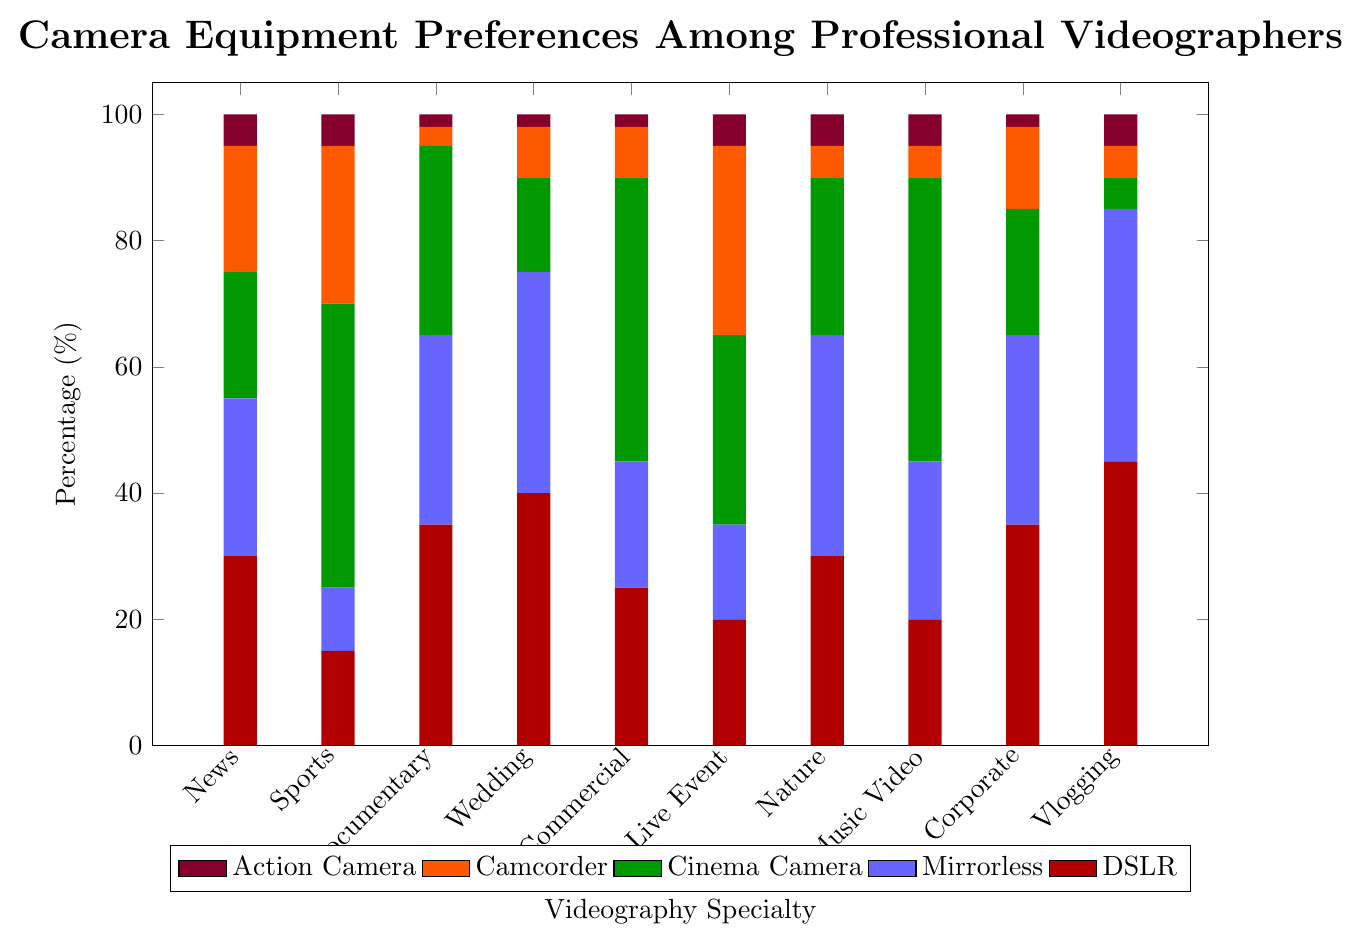Which specialty has the highest percentage of DSLR usage? To find this, we need to look at the red bars representing DSLR usage and identify the tallest one. The tallest bar for DSLR is in the "Vlogging/Social Media" specialty.
Answer: Vlogging/Social Media What is the difference in Cinema Camera usage between "Sports Broadcasting" and "Corporate Video"? First, locate the green bars representing Cinema Camera usage. In "Sports Broadcasting," the Cinema Camera usage is 45%. In "Corporate Video," it is 20%. The difference is calculated as 45 - 20.
Answer: 25% Which specialty has the lowest usage of Mirrorless cameras? To find this, identify the shortest blue bar, representing Mirrorless camera usage. The shortest blue bar is in the "Sports Broadcasting" specialty with a height of 10%.
Answer: Sports Broadcasting How much more preferred are DSLRs compared to Cinema Cameras in "Wedding Videography"? For "Wedding Videography," the usage of DSLRs is 40% (red bar) and Cinema Cameras is 15% (green bar). The difference is 40 - 15.
Answer: 25% What is the total usage percentage of DSLR and Mirrorless cameras in "Documentary Filmmaking"? In "Documentary Filmmaking," DSLRs have a usage of 35% and Mirrorless cameras have a usage of 30%. The total is 35 + 30.
Answer: 65% Which specialty prefers Action Cameras the least? Locate the shortest purple bar, representing Action Camera usage. The shortest bar appears across multiple specialties (Documentary Filmmaking, Wedding Videography, Commercial Production, Corporate Video), all at 2%.
Answer: Documentary Filmmaking, Wedding Videography, Commercial Production, Corporate Video In which specialty are Camcorders used more than Mirrorless cameras? Compare the orange bars (Camcorders) and blue bars (Mirrorless) for each specialty to find where the orange bars are taller. This condition is met in "Live Event Coverage."
Answer: Live Event Coverage What is the combined usage of Cinema Cameras and Camcorders in "Nature/Wildlife Filming"? Cinema Cameras have a usage of 25% (green bar) and Camcorders have a usage of 5% (orange bar) in "Nature/Wildlife Filming." The total is 25 + 5.
Answer: 30% How much higher is DSLR usage in "Vlogging/Social Media" compared to "News Videography"? DSLRs are used 45% in "Vlogging/Social Media" and 30% in "News Videography." The difference is 45 - 30.
Answer: 15% In which specialties do Mirrorless cameras have a higher usage than Cinema Cameras? Compare blue and green bars for each specialty and identify where blue bars are taller. This is true for "News Videography," "Wedding Videography," "Nature/Wildlife Filming," and "Corporate Video."
Answer: News Videography, Wedding Videography, Nature/Wildlife Filming, Corporate Video 